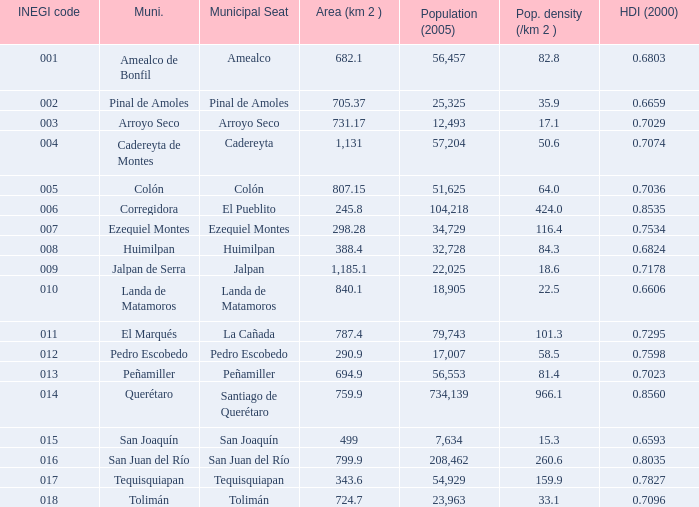WHich INEGI code has a Population density (/km 2 ) smaller than 81.4 and 0.6593 Human Development Index (2000)? 15.0. 